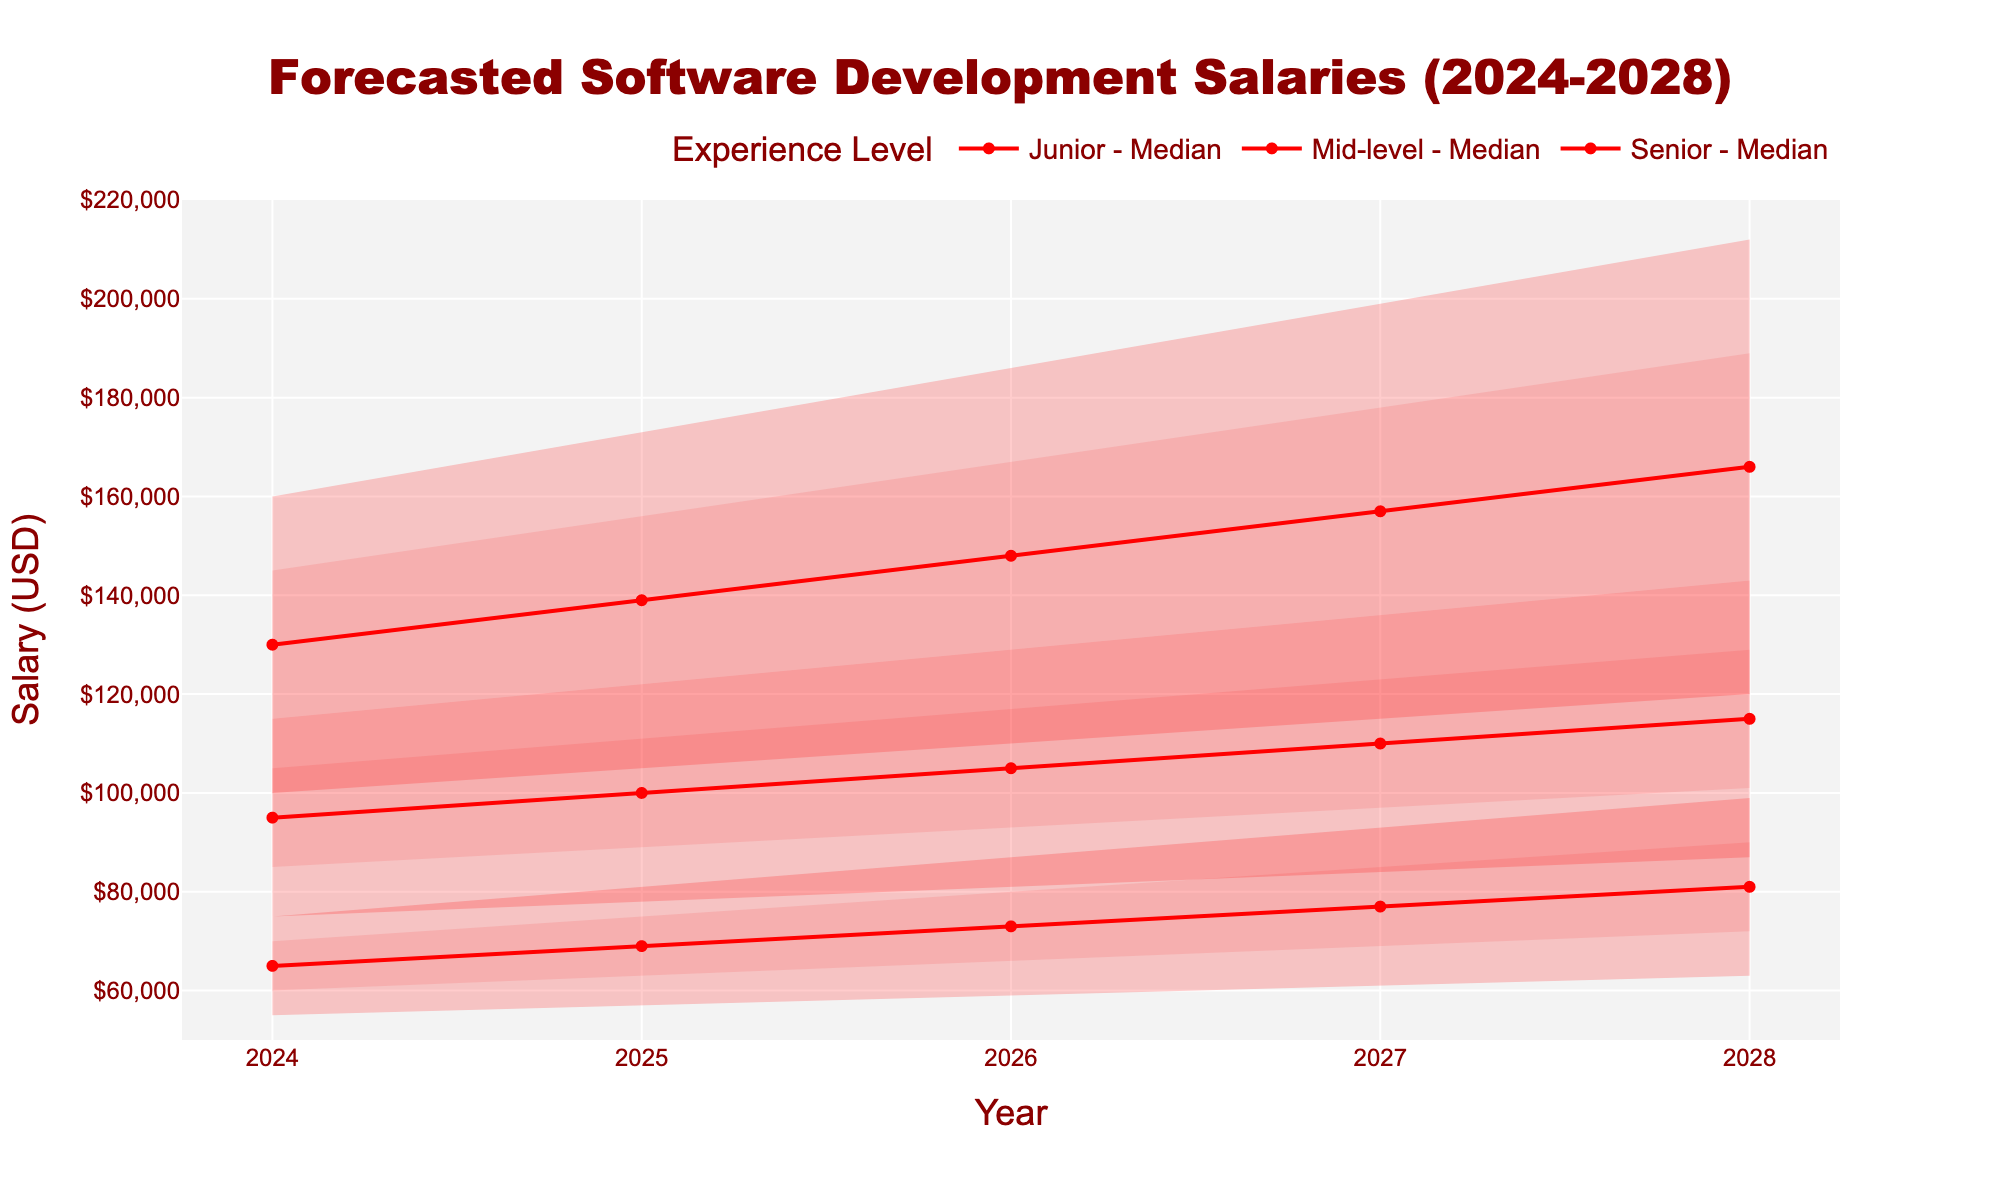What is the title of the chart? The title of the chart is shown at the top center and reads "Forecasted Software Development Salaries (2024-2028)".
Answer: Forecasted Software Development Salaries (2024-2028) What is the median salary for Mid-level developers in 2026? The fan chart shows a red line representing the median salary for each experience level. For Mid-level developers in 2026, the red line shows a salary of $105,000.
Answer: $105,000 Which experience level is forecasted to have the highest salary in 2028? The highest salary forecasted in 2028 can be found by looking at the top boundary of the red shaded areas. For Senior developers, the high estimate reaches $212,000, which is higher than for Junior and Mid-level developers.
Answer: Senior How does the median salary for Junior developers change from 2024 to 2028? Locate the median values for Junior developers in 2024 ($65,000) and 2028 ($81,000), then calculate the difference. The median salary increases by $81,000 - $65,000 = $16,000.
Answer: $16,000 What is the range of salaries (from low to high) for Senior developers in 2025? The low and high values for Senior developers in 2025 are shown as $105,000 (low) and $173,000 (high). The range is calculated as $173,000 - $105,000 = $68,000.
Answer: $68,000 In which year do Senior developers have a median salary of $130,000? Trace the red median line for Senior developers across years. In 2024, the median salary is $130,000.
Answer: 2024 Compare the forecasted high salaries for Mid-level developers between 2024 and 2028. The high salary for Mid-level developers in 2024 is $115,000. In 2028, the high salary rises to $143,000. The difference is $143,000 - $115,000 = $28,000.
Answer: $28,000 What is the average forecasted median salary for Junior developers over the 5-year period? Calculate the median salaries for Junior developers each year: $65,000 (2024), $69,000 (2025), $73,000 (2026), $77,000 (2027), $81,000 (2028). The average is ($65,000 + $69,000 + $73,000 + $77,000 + $81,000) / 5 = $73,000.
Answer: $73,000 